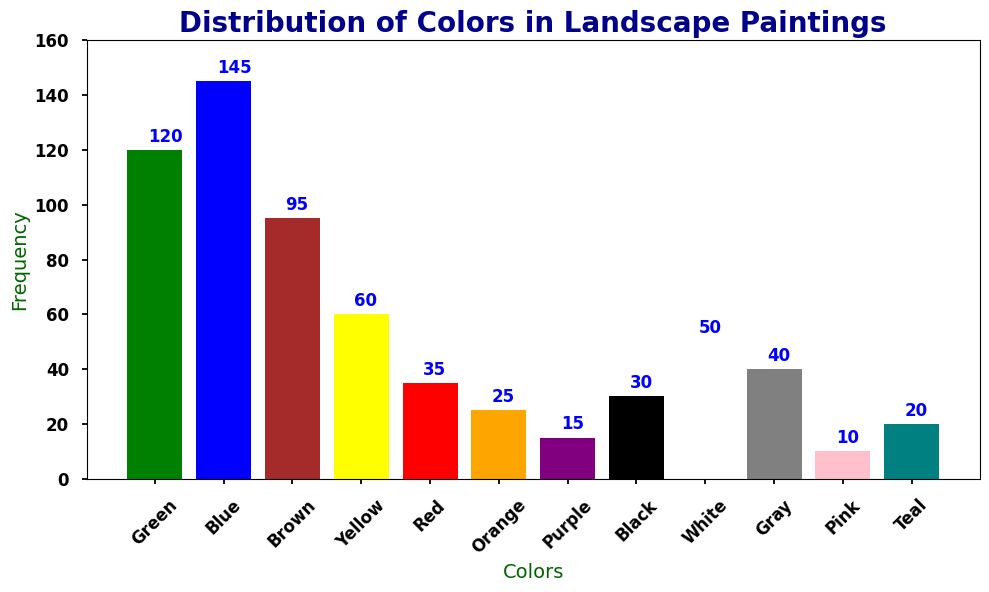What's the most frequently used color in landscape paintings? By looking at the heights of the bars, we can see that the tallest bar represents Blue with a frequency of 145. This means Blue is the most frequently used color.
Answer: Blue Which two colors have the lowest frequency in landscape paintings? By observing the bar heights, the shortest bars are for Pink with 10 and Purple with 15. These indicate the two colors with the lowest frequency.
Answer: Pink and Purple What's the total frequency of Green, Blue, and Brown combined? To find this, add the frequencies of Green (120), Blue (145), and Brown (95). So, 120 + 145 + 95 = 360.
Answer: 360 If you combine the frequency of Red and Yellow, do they surpass the frequency of Blue? Red frequency is 35 and Yellow is 60, their combined frequency is 35 + 60 = 95. Since the frequency of Blue is 145, 95 is less than 145.
Answer: No What is the average frequency of Black, White, and Gray? The frequencies are Black (30), White (50), and Gray (40). Calculate the average by summing these frequencies and dividing by 3: (30 + 50 + 40) / 3 = 120 / 3 = 40.
Answer: 40 Which color has a similar frequency to white? White has a frequency of 50. Observing the plot, the frequency bar of Brown also stands near 50, specifically at 95.
Answer: Brown How many colors have a frequency less than 50? The colors with frequencies less than 50 are Red (35), Orange (25), Purple (15), Black (30), Gray (40), Pink (10), and Teal (20). Counting these gives us 7 colors.
Answer: 7 What is the frequency difference between the most and least used colors? The most used color is Blue with a frequency of 145 and the least used is Pink with a frequency of 10. The difference is 145 - 10 = 135.
Answer: 135 What percentage of the total frequency does the color Yellow represent? The frequency for Yellow is 60. The total frequency is obtained by summing all frequencies: 120 + 145 + 95 + 60 + 35 + 25 + 15 + 30 + 50 + 40 + 10 + 20 = 645. The percentage is (60 / 645) * 100 = 9.3% (approximately).
Answer: 9.3% Is Teal more frequent than Pink and Purple combined? Frequencies are Teal (20), Pink (10), and Purple (15). Combined Pink and Purple is 10 + 15 = 25. Since 20 < 25, Teal is not more frequent.
Answer: No 